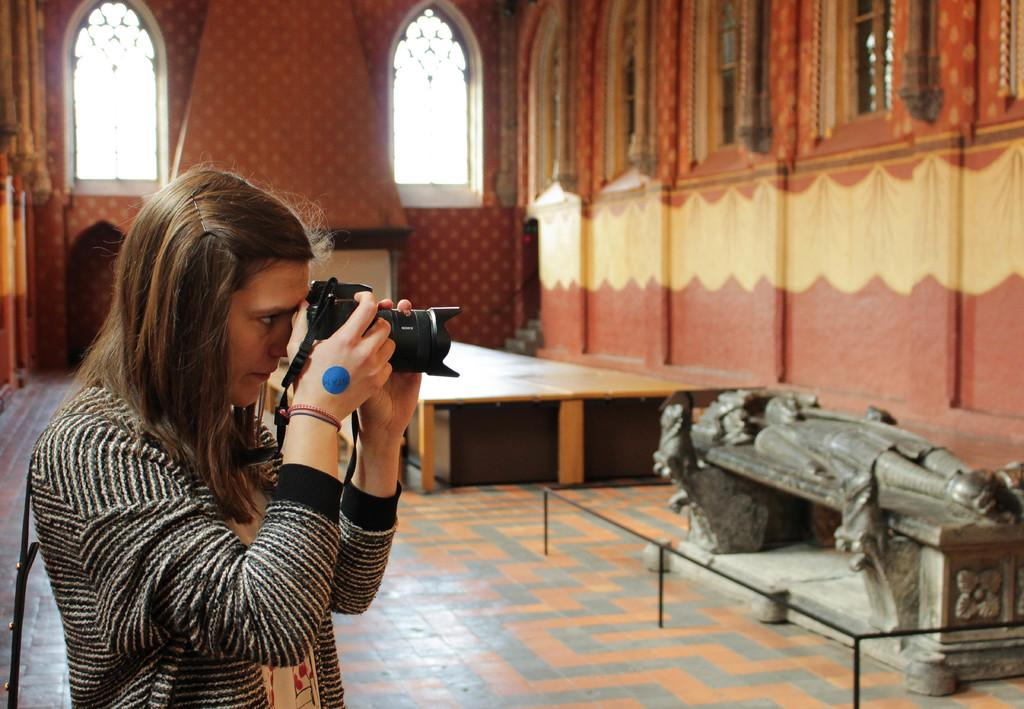Who is the main subject in the image? There is a woman in the image. What is the woman doing in the image? The woman is taking a picture, as she is holding a camera with her hand. What can be seen in the background of the image? There is a sculpture, a fence, a table, a wall, and windows in the image. What type of health advice can be seen on the sculpture in the image? There is no health advice present on the sculpture in the image. How many things are visible in the image? It is not clear what "things" refers to in this context, but the image contains a woman, a camera, a sculpture, a fence, a table, a wall, and windows. 